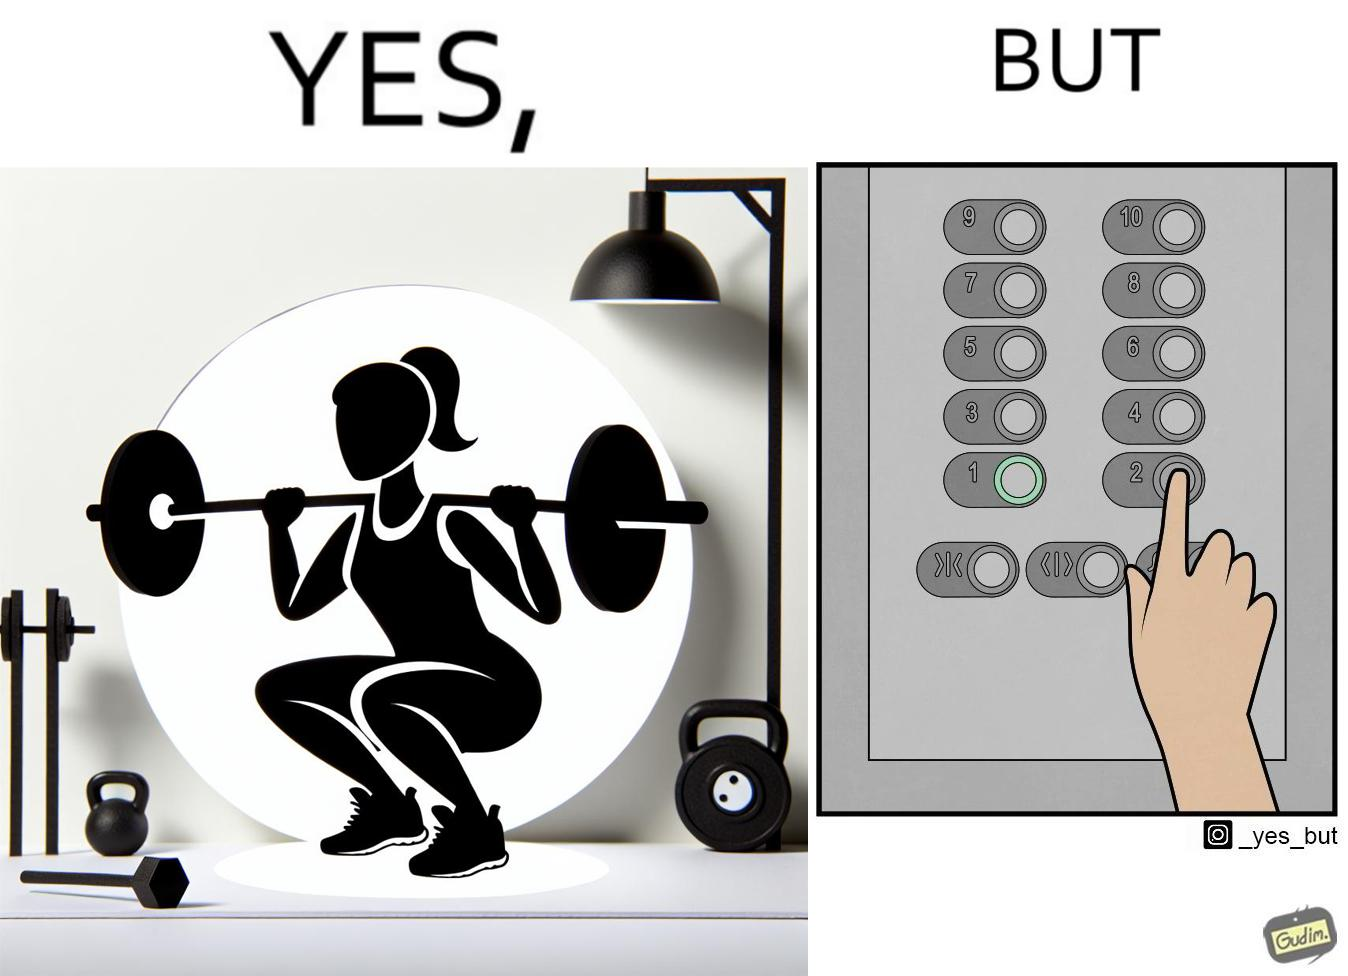Explain why this image is satirical. The image is satirical because it shows that while people do various kinds of exercises and go to gym to stay fit, they avoid doing simplest of physical tasks like using stairs instead of elevators to get to even the first or the second floor of a building. 